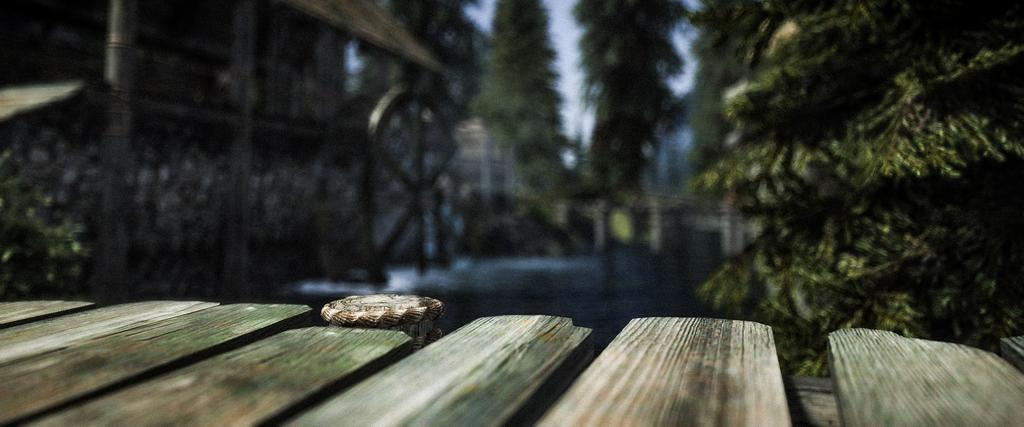What type of structure is present in the image? There is a wooden bridge in the image. What is the bridge situated over? The bridge is over water. What can be seen in the background of the image? There are trees and houses visible in the image. What type of pies are being sold by the company near the bridge in the image? There is no mention of a company or pies in the image; it only features a wooden bridge over water with trees and houses in the background. 